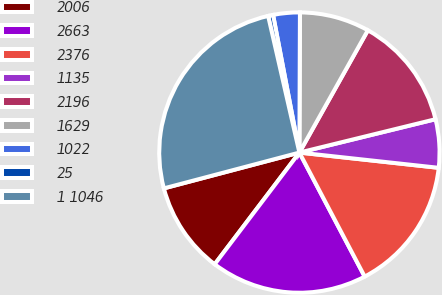Convert chart. <chart><loc_0><loc_0><loc_500><loc_500><pie_chart><fcel>2006<fcel>2663<fcel>2376<fcel>1135<fcel>2196<fcel>1629<fcel>1022<fcel>25<fcel>1 1046<nl><fcel>10.56%<fcel>18.04%<fcel>15.55%<fcel>5.56%<fcel>13.05%<fcel>8.06%<fcel>3.07%<fcel>0.57%<fcel>25.53%<nl></chart> 